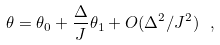Convert formula to latex. <formula><loc_0><loc_0><loc_500><loc_500>\theta = \theta _ { 0 } + \frac { \Delta } { J } \theta _ { 1 } + O ( \Delta ^ { 2 } / J ^ { 2 } ) \ ,</formula> 